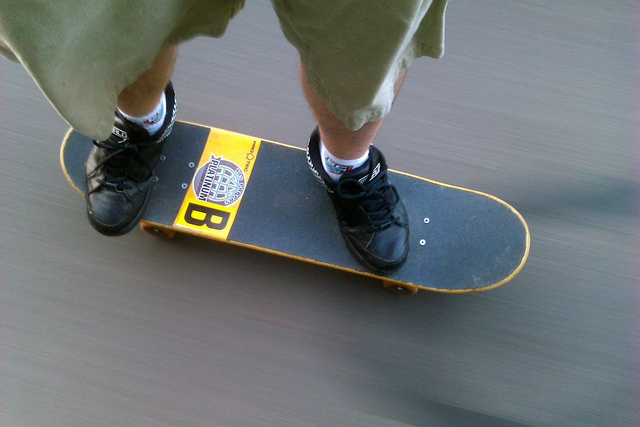Describe the objects in this image and their specific colors. I can see people in gray, darkgreen, and black tones and skateboard in gray, blue, and black tones in this image. 